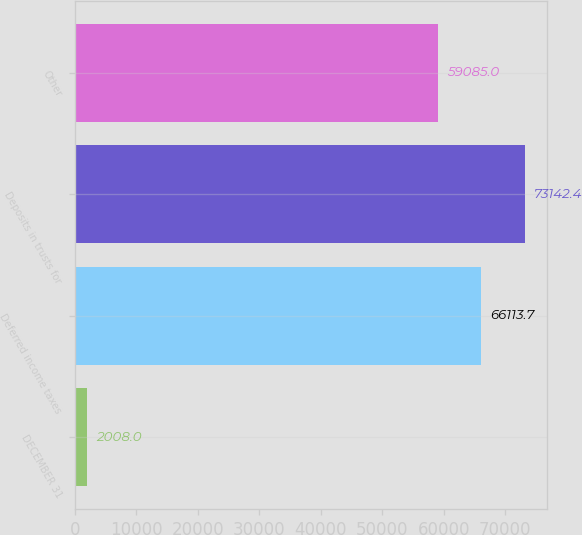<chart> <loc_0><loc_0><loc_500><loc_500><bar_chart><fcel>DECEMBER 31<fcel>Deferred income taxes<fcel>Deposits in trusts for<fcel>Other<nl><fcel>2008<fcel>66113.7<fcel>73142.4<fcel>59085<nl></chart> 